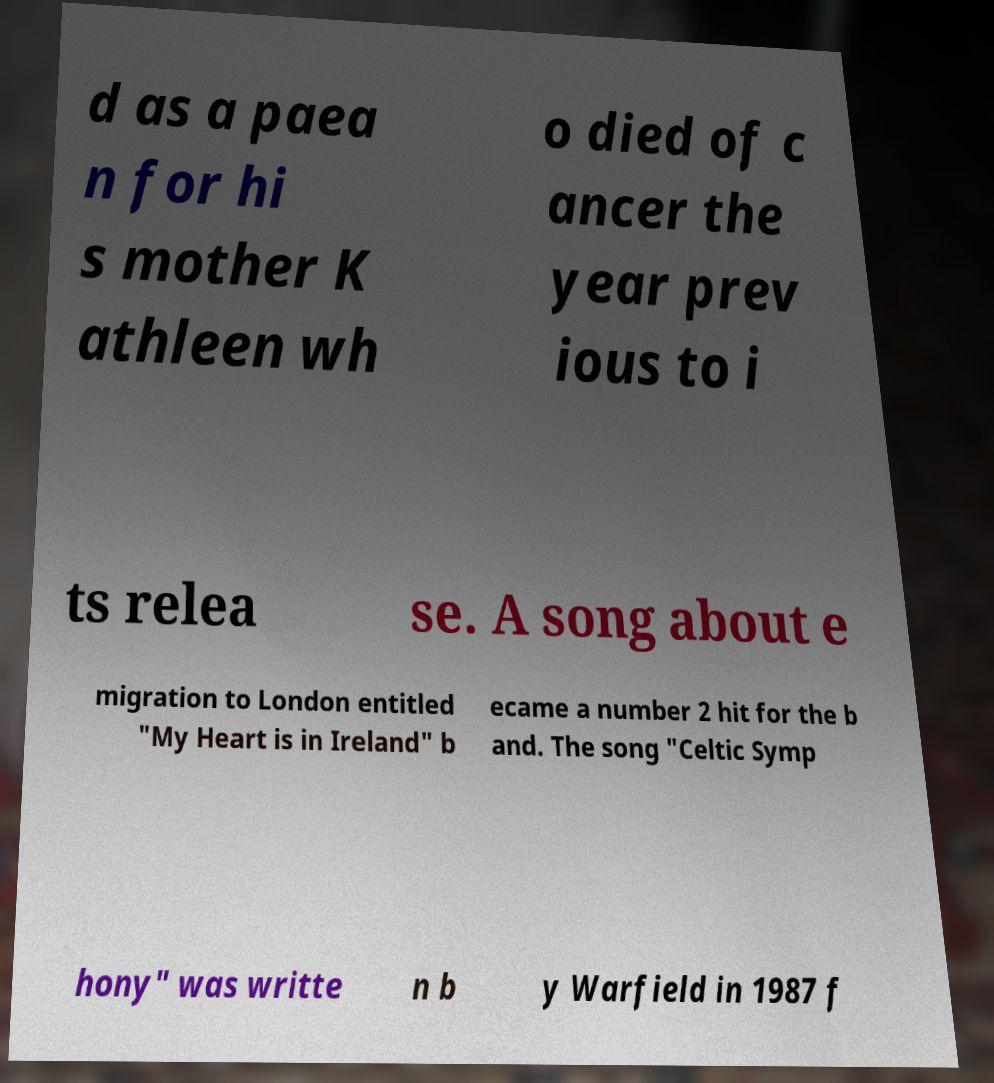For documentation purposes, I need the text within this image transcribed. Could you provide that? d as a paea n for hi s mother K athleen wh o died of c ancer the year prev ious to i ts relea se. A song about e migration to London entitled "My Heart is in Ireland" b ecame a number 2 hit for the b and. The song "Celtic Symp hony" was writte n b y Warfield in 1987 f 